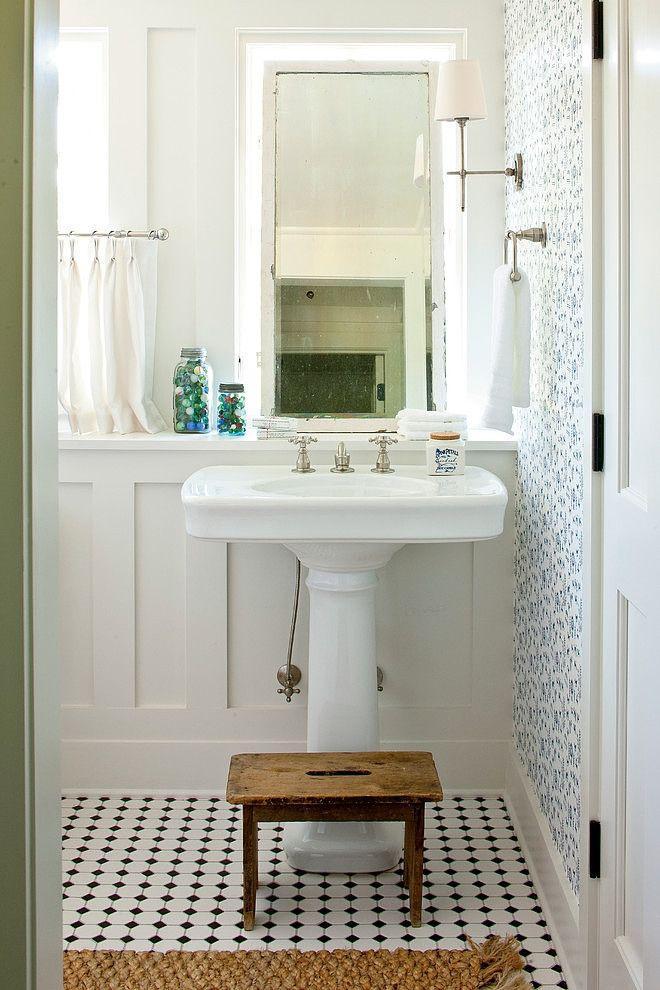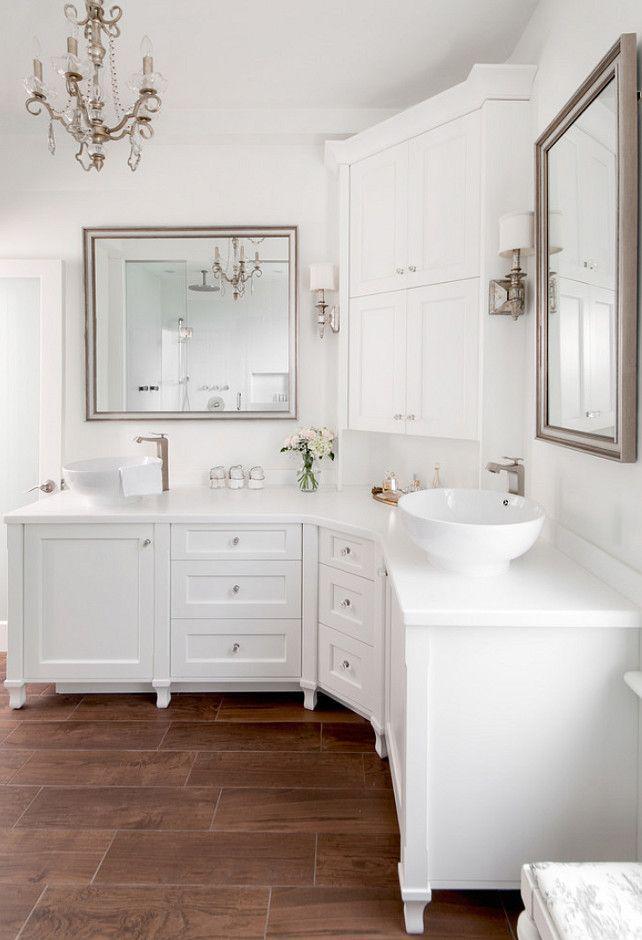The first image is the image on the left, the second image is the image on the right. Evaluate the accuracy of this statement regarding the images: "In 1 of the images, 1 sink has a window behind it.". Is it true? Answer yes or no. No. 